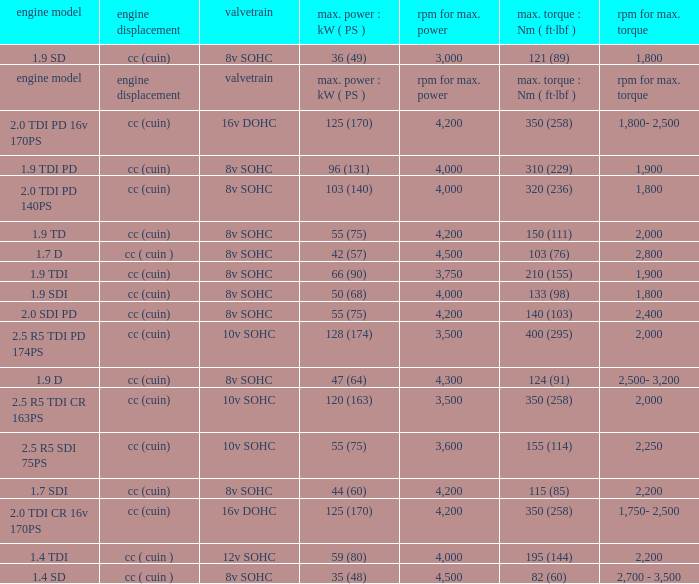What is the valvetrain with an engine model that is engine model? Valvetrain. 